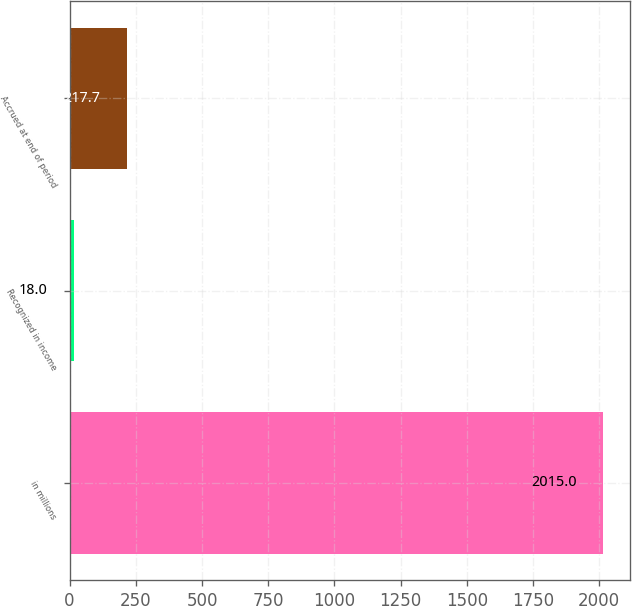<chart> <loc_0><loc_0><loc_500><loc_500><bar_chart><fcel>in millions<fcel>Recognized in income<fcel>Accrued at end of period<nl><fcel>2015<fcel>18<fcel>217.7<nl></chart> 